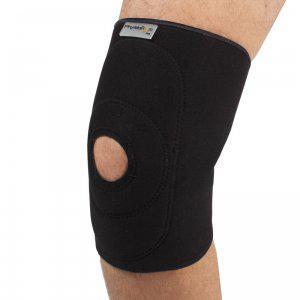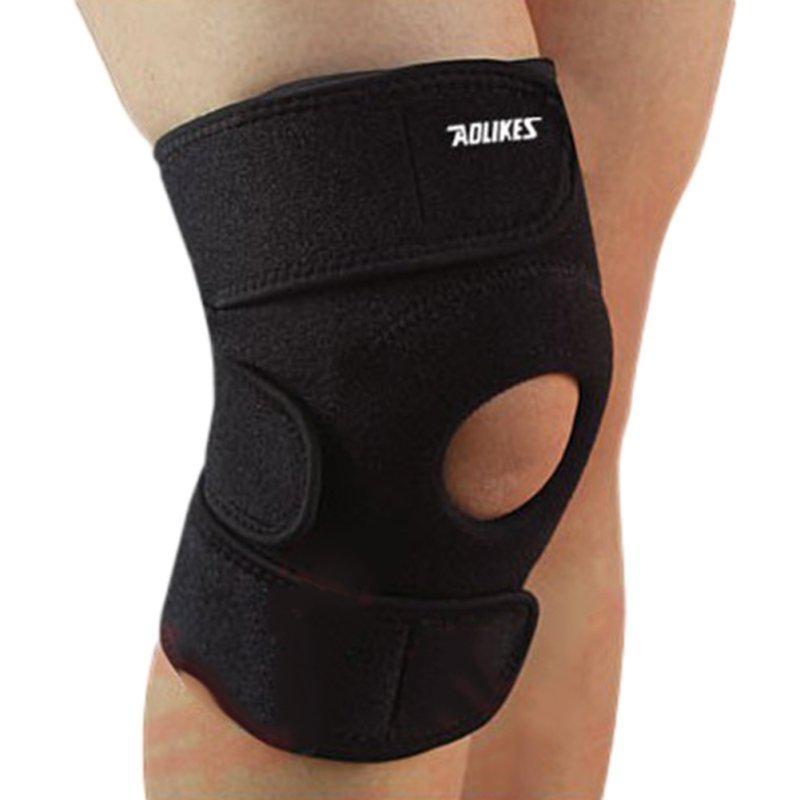The first image is the image on the left, the second image is the image on the right. For the images displayed, is the sentence "One of the knee-pads has Velcro around the top and one does not." factually correct? Answer yes or no. Yes. 